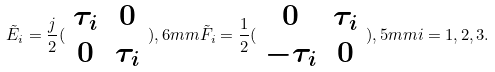Convert formula to latex. <formula><loc_0><loc_0><loc_500><loc_500>\tilde { E } _ { i } = \frac { j } { 2 } ( \begin{array} { c c } \tau _ { i } & 0 \\ 0 & \tau _ { i } \end{array} ) , 6 m m \tilde { F } _ { i } = \frac { 1 } { 2 } ( \begin{array} { c c } 0 & \tau _ { i } \\ - \tau _ { i } & 0 \end{array} ) , 5 m m i = 1 , 2 , 3 .</formula> 